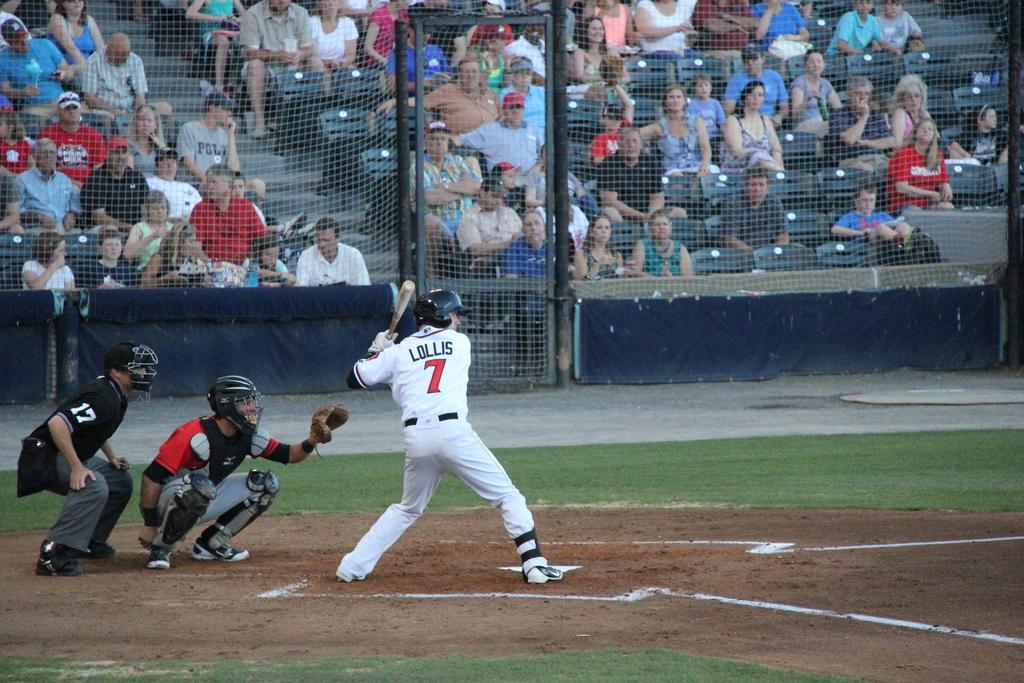<image>
Render a clear and concise summary of the photo. A man is in a white baseball uniform that says "LOLLIS" on the back. 